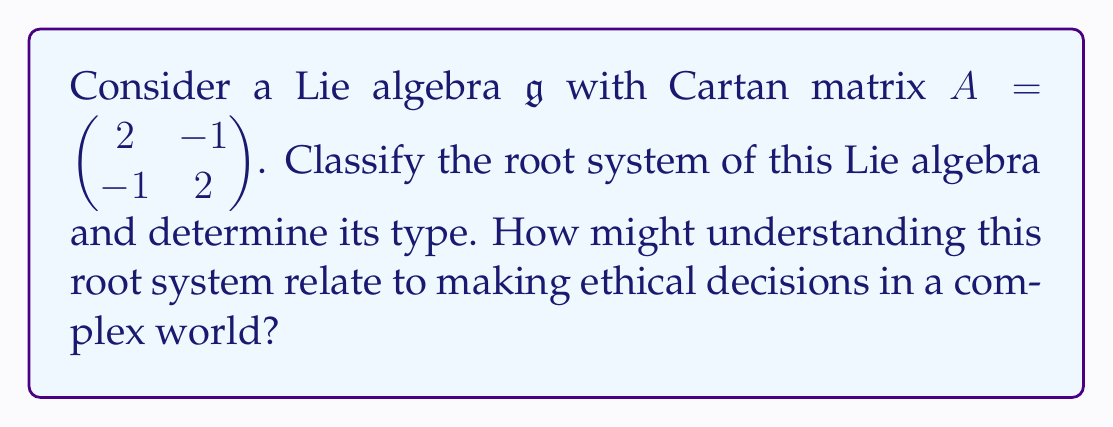Teach me how to tackle this problem. To classify the root system of this semisimple Lie algebra, we'll follow these steps:

1) First, we need to recognize that the given Cartan matrix corresponds to a rank-2 Lie algebra.

2) The Cartan matrix $A = \begin{pmatrix} 2 & -1 \\ -1 & 2 \end{pmatrix}$ is symmetric, which indicates that the corresponding Dynkin diagram will be simply-laced (all roots have the same length).

3) We can construct the Dynkin diagram from the Cartan matrix:
   - Two nodes (corresponding to the two simple roots)
   - An edge between the nodes (because $a_{12} = a_{21} = -1$)

4) This Dynkin diagram corresponds to the $A_2$ root system.

5) The $A_2$ root system has the following properties:
   - It has 6 roots in total (including positive and negative roots)
   - The roots can be represented in a 2D plane as the vertices of a regular hexagon

[asy]
unitsize(1cm);
draw(circle((0,0),2),gray);
dot((2,0),red);
dot((1,sqrt(3)),red);
dot((-1,sqrt(3)),red);
dot((-2,0),red);
dot((-1,-sqrt(3)),red);
dot((1,-sqrt(3)),red);
label("$\alpha_1$",(2,0),E);
label("$\alpha_1+\alpha_2$",(1,sqrt(3)),NE);
label("$\alpha_2$",(-1,sqrt(3)),NW);
label("$-\alpha_1$",(-2,0),W);
label("$-(\alpha_1+\alpha_2)$",(-1,-sqrt(3)),SW);
label("$-\alpha_2$",(1,-sqrt(3)),SE);
[/asy]

6) The $A_2$ root system corresponds to the Lie algebra $\mathfrak{sl}(3,\mathbb{C})$, which is the special linear algebra of 3x3 complex matrices with trace zero.

Relating this to ethical decision-making in a complex world:
Understanding root systems and Lie algebras can be seen as a metaphor for comprehending complex systems of relationships and influences. Just as the root system describes the fundamental structure of a Lie algebra, ethical principles form the foundation of moral decision-making. The interconnectedness of roots (like $\alpha_1 + \alpha_2$) mirrors how our choices often have compound effects. Recognizing these intricate relationships can help in navigating the complexities of ethical dilemmas, much like how understanding the structure of a Lie algebra helps in solving problems in physics or mathematics.
Answer: The root system of the given Lie algebra is of type $A_2$, corresponding to the Lie algebra $\mathfrak{sl}(3,\mathbb{C})$. 